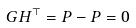<formula> <loc_0><loc_0><loc_500><loc_500>G H ^ { \top } = P - P = 0</formula> 